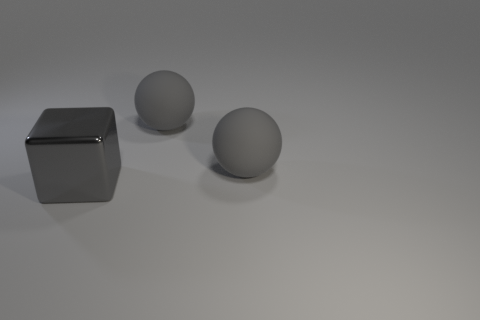Subtract all balls. How many objects are left? 1 Subtract 0 red cubes. How many objects are left? 3 Subtract 2 spheres. How many spheres are left? 0 Subtract all green blocks. Subtract all cyan balls. How many blocks are left? 1 Subtract all metallic cubes. Subtract all tiny blue metal cubes. How many objects are left? 2 Add 2 large shiny objects. How many large shiny objects are left? 3 Add 2 big metallic objects. How many big metallic objects exist? 3 Add 2 blocks. How many objects exist? 5 